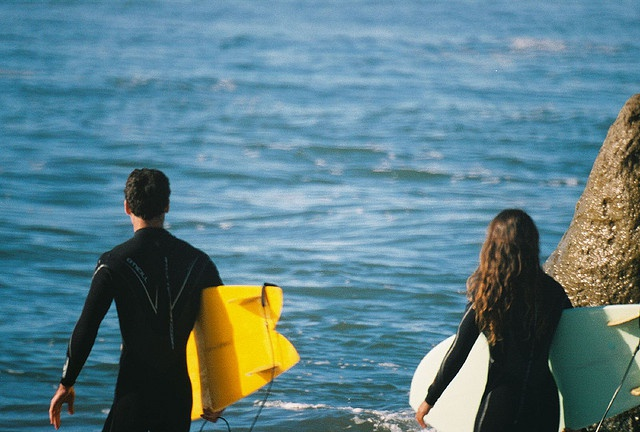Describe the objects in this image and their specific colors. I can see people in teal, black, gray, and maroon tones, people in teal, black, maroon, and gray tones, surfboard in teal, beige, and black tones, and surfboard in teal, gold, olive, and orange tones in this image. 